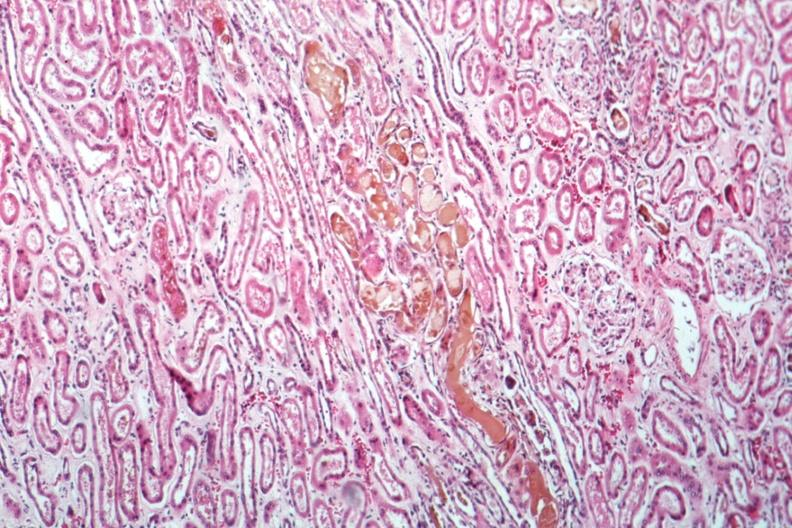where is this?
Answer the question using a single word or phrase. Urinary 